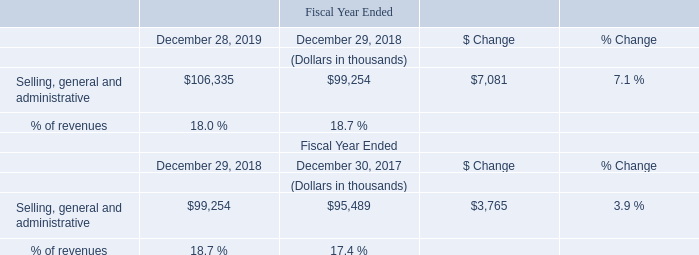Selling, General and Administrative
The increase in selling, general and administrative in fiscal 2019 compared to fiscal 2018 was primarily due to higher variable costs on increased sales volumes, primarily related to increases in headcount costs and employee incentive compensation, as well as additional costs from the FRT acquisition, offset partially by a decrease in the amortization of intangible assets.
What led to increase in selling, general and administrative in fiscal 2019 compared to fiscal 2018? The increase in selling, general and administrative in fiscal 2019 compared to fiscal 2018 was primarily due to higher variable costs on increased sales volumes. What is the average Selling, general and administrative for the Fiscal Year Ended December 28, 2019 to December 29, 2018?  
Answer scale should be: thousand. (106,335+99,254) / 2
Answer: 102794.5. What is the average Selling, general and administrative for the Fiscal Year Ended December 29, 2018 to December 30, 2017?
Answer scale should be: thousand. (99,254+95,489) / 2
Answer: 97371.5. In which year was Selling, general and administrative less than 100,000 thousands? Locate and analyze the selling, general and administrative in row 4
answer: 2018, 2017. What is the percentage of revenue in 2019 and 2018?
Answer scale should be: percent. 18.0, 18.7, . What was the Selling, general and administrative in 2018 and 2017?
Answer scale should be: thousand. 99,254, 95,489. 